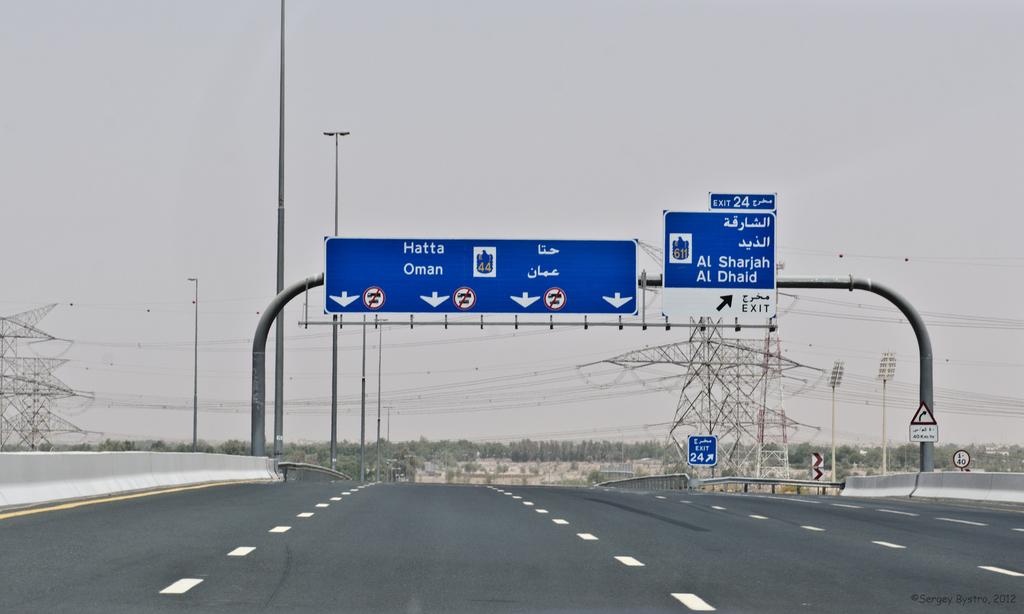What is the next exit number?
Your answer should be very brief. 24. Go straight on towards what city?
Ensure brevity in your answer.  Hatta. 